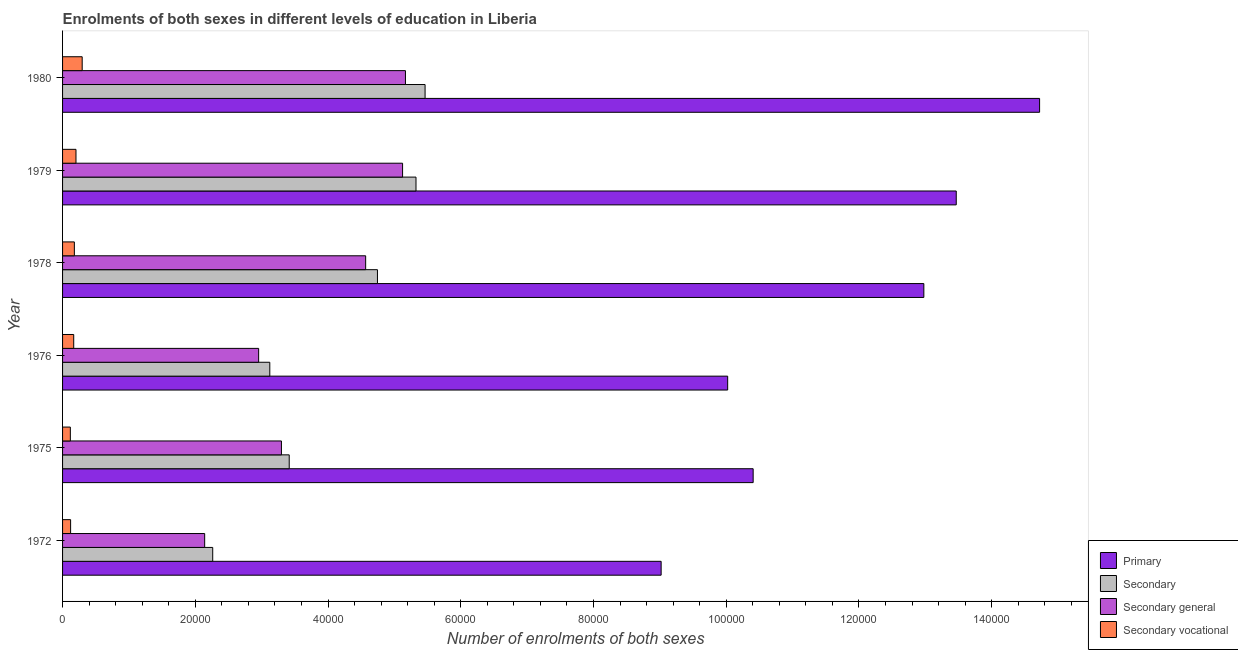How many different coloured bars are there?
Make the answer very short. 4. How many groups of bars are there?
Provide a short and direct response. 6. Are the number of bars on each tick of the Y-axis equal?
Your answer should be very brief. Yes. How many bars are there on the 5th tick from the top?
Provide a short and direct response. 4. How many bars are there on the 1st tick from the bottom?
Offer a very short reply. 4. What is the label of the 3rd group of bars from the top?
Provide a short and direct response. 1978. What is the number of enrolments in primary education in 1980?
Your response must be concise. 1.47e+05. Across all years, what is the maximum number of enrolments in secondary general education?
Make the answer very short. 5.17e+04. Across all years, what is the minimum number of enrolments in secondary general education?
Your answer should be very brief. 2.14e+04. In which year was the number of enrolments in secondary vocational education minimum?
Give a very brief answer. 1975. What is the total number of enrolments in primary education in the graph?
Your answer should be compact. 7.06e+05. What is the difference between the number of enrolments in secondary general education in 1979 and that in 1980?
Offer a very short reply. -435. What is the difference between the number of enrolments in secondary general education in 1978 and the number of enrolments in secondary vocational education in 1976?
Your response must be concise. 4.40e+04. What is the average number of enrolments in secondary vocational education per year?
Offer a very short reply. 1804. In the year 1978, what is the difference between the number of enrolments in secondary education and number of enrolments in secondary vocational education?
Offer a terse response. 4.57e+04. In how many years, is the number of enrolments in secondary general education greater than 60000 ?
Keep it short and to the point. 0. What is the ratio of the number of enrolments in secondary education in 1976 to that in 1978?
Keep it short and to the point. 0.66. What is the difference between the highest and the second highest number of enrolments in primary education?
Offer a terse response. 1.26e+04. What is the difference between the highest and the lowest number of enrolments in secondary general education?
Your answer should be very brief. 3.03e+04. Is the sum of the number of enrolments in primary education in 1979 and 1980 greater than the maximum number of enrolments in secondary education across all years?
Offer a very short reply. Yes. Is it the case that in every year, the sum of the number of enrolments in secondary vocational education and number of enrolments in secondary education is greater than the sum of number of enrolments in primary education and number of enrolments in secondary general education?
Your response must be concise. Yes. What does the 3rd bar from the top in 1980 represents?
Offer a very short reply. Secondary. What does the 4th bar from the bottom in 1976 represents?
Provide a succinct answer. Secondary vocational. How many years are there in the graph?
Make the answer very short. 6. What is the difference between two consecutive major ticks on the X-axis?
Keep it short and to the point. 2.00e+04. Are the values on the major ticks of X-axis written in scientific E-notation?
Keep it short and to the point. No. Does the graph contain any zero values?
Make the answer very short. No. How many legend labels are there?
Keep it short and to the point. 4. What is the title of the graph?
Ensure brevity in your answer.  Enrolments of both sexes in different levels of education in Liberia. What is the label or title of the X-axis?
Offer a terse response. Number of enrolments of both sexes. What is the label or title of the Y-axis?
Your response must be concise. Year. What is the Number of enrolments of both sexes of Primary in 1972?
Your answer should be very brief. 9.02e+04. What is the Number of enrolments of both sexes in Secondary in 1972?
Offer a very short reply. 2.26e+04. What is the Number of enrolments of both sexes in Secondary general in 1972?
Give a very brief answer. 2.14e+04. What is the Number of enrolments of both sexes in Secondary vocational in 1972?
Your response must be concise. 1213. What is the Number of enrolments of both sexes of Primary in 1975?
Offer a very short reply. 1.04e+05. What is the Number of enrolments of both sexes in Secondary in 1975?
Your answer should be very brief. 3.42e+04. What is the Number of enrolments of both sexes in Secondary general in 1975?
Ensure brevity in your answer.  3.30e+04. What is the Number of enrolments of both sexes of Secondary vocational in 1975?
Keep it short and to the point. 1173. What is the Number of enrolments of both sexes in Primary in 1976?
Provide a succinct answer. 1.00e+05. What is the Number of enrolments of both sexes of Secondary in 1976?
Offer a very short reply. 3.12e+04. What is the Number of enrolments of both sexes of Secondary general in 1976?
Your answer should be very brief. 2.95e+04. What is the Number of enrolments of both sexes of Secondary vocational in 1976?
Provide a succinct answer. 1680. What is the Number of enrolments of both sexes of Primary in 1978?
Your answer should be compact. 1.30e+05. What is the Number of enrolments of both sexes in Secondary in 1978?
Make the answer very short. 4.74e+04. What is the Number of enrolments of both sexes in Secondary general in 1978?
Keep it short and to the point. 4.57e+04. What is the Number of enrolments of both sexes in Secondary vocational in 1978?
Offer a terse response. 1778. What is the Number of enrolments of both sexes of Primary in 1979?
Offer a very short reply. 1.35e+05. What is the Number of enrolments of both sexes of Secondary in 1979?
Your answer should be very brief. 5.33e+04. What is the Number of enrolments of both sexes of Secondary general in 1979?
Keep it short and to the point. 5.12e+04. What is the Number of enrolments of both sexes of Secondary vocational in 1979?
Make the answer very short. 2023. What is the Number of enrolments of both sexes in Primary in 1980?
Give a very brief answer. 1.47e+05. What is the Number of enrolments of both sexes of Secondary in 1980?
Provide a short and direct response. 5.46e+04. What is the Number of enrolments of both sexes of Secondary general in 1980?
Your answer should be compact. 5.17e+04. What is the Number of enrolments of both sexes in Secondary vocational in 1980?
Your answer should be very brief. 2957. Across all years, what is the maximum Number of enrolments of both sexes of Primary?
Provide a succinct answer. 1.47e+05. Across all years, what is the maximum Number of enrolments of both sexes in Secondary?
Ensure brevity in your answer.  5.46e+04. Across all years, what is the maximum Number of enrolments of both sexes in Secondary general?
Offer a terse response. 5.17e+04. Across all years, what is the maximum Number of enrolments of both sexes in Secondary vocational?
Ensure brevity in your answer.  2957. Across all years, what is the minimum Number of enrolments of both sexes of Primary?
Your response must be concise. 9.02e+04. Across all years, what is the minimum Number of enrolments of both sexes of Secondary?
Ensure brevity in your answer.  2.26e+04. Across all years, what is the minimum Number of enrolments of both sexes of Secondary general?
Make the answer very short. 2.14e+04. Across all years, what is the minimum Number of enrolments of both sexes of Secondary vocational?
Your response must be concise. 1173. What is the total Number of enrolments of both sexes of Primary in the graph?
Make the answer very short. 7.06e+05. What is the total Number of enrolments of both sexes of Secondary in the graph?
Make the answer very short. 2.43e+05. What is the total Number of enrolments of both sexes in Secondary general in the graph?
Ensure brevity in your answer.  2.32e+05. What is the total Number of enrolments of both sexes of Secondary vocational in the graph?
Your answer should be very brief. 1.08e+04. What is the difference between the Number of enrolments of both sexes in Primary in 1972 and that in 1975?
Provide a succinct answer. -1.39e+04. What is the difference between the Number of enrolments of both sexes of Secondary in 1972 and that in 1975?
Offer a very short reply. -1.15e+04. What is the difference between the Number of enrolments of both sexes in Secondary general in 1972 and that in 1975?
Your answer should be compact. -1.16e+04. What is the difference between the Number of enrolments of both sexes of Primary in 1972 and that in 1976?
Provide a short and direct response. -1.00e+04. What is the difference between the Number of enrolments of both sexes in Secondary in 1972 and that in 1976?
Provide a succinct answer. -8600. What is the difference between the Number of enrolments of both sexes in Secondary general in 1972 and that in 1976?
Your response must be concise. -8133. What is the difference between the Number of enrolments of both sexes of Secondary vocational in 1972 and that in 1976?
Provide a succinct answer. -467. What is the difference between the Number of enrolments of both sexes of Primary in 1972 and that in 1978?
Keep it short and to the point. -3.96e+04. What is the difference between the Number of enrolments of both sexes in Secondary in 1972 and that in 1978?
Offer a terse response. -2.48e+04. What is the difference between the Number of enrolments of both sexes of Secondary general in 1972 and that in 1978?
Ensure brevity in your answer.  -2.43e+04. What is the difference between the Number of enrolments of both sexes of Secondary vocational in 1972 and that in 1978?
Your answer should be compact. -565. What is the difference between the Number of enrolments of both sexes of Primary in 1972 and that in 1979?
Keep it short and to the point. -4.45e+04. What is the difference between the Number of enrolments of both sexes in Secondary in 1972 and that in 1979?
Provide a succinct answer. -3.06e+04. What is the difference between the Number of enrolments of both sexes of Secondary general in 1972 and that in 1979?
Keep it short and to the point. -2.98e+04. What is the difference between the Number of enrolments of both sexes in Secondary vocational in 1972 and that in 1979?
Provide a succinct answer. -810. What is the difference between the Number of enrolments of both sexes of Primary in 1972 and that in 1980?
Offer a very short reply. -5.70e+04. What is the difference between the Number of enrolments of both sexes of Secondary in 1972 and that in 1980?
Offer a terse response. -3.20e+04. What is the difference between the Number of enrolments of both sexes in Secondary general in 1972 and that in 1980?
Your answer should be compact. -3.03e+04. What is the difference between the Number of enrolments of both sexes in Secondary vocational in 1972 and that in 1980?
Provide a short and direct response. -1744. What is the difference between the Number of enrolments of both sexes in Primary in 1975 and that in 1976?
Provide a short and direct response. 3839. What is the difference between the Number of enrolments of both sexes of Secondary in 1975 and that in 1976?
Provide a short and direct response. 2927. What is the difference between the Number of enrolments of both sexes of Secondary general in 1975 and that in 1976?
Offer a very short reply. 3434. What is the difference between the Number of enrolments of both sexes of Secondary vocational in 1975 and that in 1976?
Offer a terse response. -507. What is the difference between the Number of enrolments of both sexes in Primary in 1975 and that in 1978?
Provide a short and direct response. -2.57e+04. What is the difference between the Number of enrolments of both sexes of Secondary in 1975 and that in 1978?
Offer a terse response. -1.33e+04. What is the difference between the Number of enrolments of both sexes in Secondary general in 1975 and that in 1978?
Your answer should be very brief. -1.27e+04. What is the difference between the Number of enrolments of both sexes of Secondary vocational in 1975 and that in 1978?
Your answer should be compact. -605. What is the difference between the Number of enrolments of both sexes in Primary in 1975 and that in 1979?
Provide a succinct answer. -3.06e+04. What is the difference between the Number of enrolments of both sexes of Secondary in 1975 and that in 1979?
Your response must be concise. -1.91e+04. What is the difference between the Number of enrolments of both sexes of Secondary general in 1975 and that in 1979?
Keep it short and to the point. -1.83e+04. What is the difference between the Number of enrolments of both sexes in Secondary vocational in 1975 and that in 1979?
Your response must be concise. -850. What is the difference between the Number of enrolments of both sexes of Primary in 1975 and that in 1980?
Keep it short and to the point. -4.32e+04. What is the difference between the Number of enrolments of both sexes in Secondary in 1975 and that in 1980?
Offer a terse response. -2.05e+04. What is the difference between the Number of enrolments of both sexes in Secondary general in 1975 and that in 1980?
Ensure brevity in your answer.  -1.87e+04. What is the difference between the Number of enrolments of both sexes in Secondary vocational in 1975 and that in 1980?
Offer a terse response. -1784. What is the difference between the Number of enrolments of both sexes of Primary in 1976 and that in 1978?
Your answer should be compact. -2.96e+04. What is the difference between the Number of enrolments of both sexes in Secondary in 1976 and that in 1978?
Offer a very short reply. -1.62e+04. What is the difference between the Number of enrolments of both sexes in Secondary general in 1976 and that in 1978?
Your response must be concise. -1.61e+04. What is the difference between the Number of enrolments of both sexes of Secondary vocational in 1976 and that in 1978?
Offer a terse response. -98. What is the difference between the Number of enrolments of both sexes in Primary in 1976 and that in 1979?
Offer a terse response. -3.44e+04. What is the difference between the Number of enrolments of both sexes in Secondary in 1976 and that in 1979?
Your response must be concise. -2.20e+04. What is the difference between the Number of enrolments of both sexes in Secondary general in 1976 and that in 1979?
Make the answer very short. -2.17e+04. What is the difference between the Number of enrolments of both sexes of Secondary vocational in 1976 and that in 1979?
Make the answer very short. -343. What is the difference between the Number of enrolments of both sexes of Primary in 1976 and that in 1980?
Ensure brevity in your answer.  -4.70e+04. What is the difference between the Number of enrolments of both sexes of Secondary in 1976 and that in 1980?
Offer a terse response. -2.34e+04. What is the difference between the Number of enrolments of both sexes of Secondary general in 1976 and that in 1980?
Provide a succinct answer. -2.21e+04. What is the difference between the Number of enrolments of both sexes of Secondary vocational in 1976 and that in 1980?
Your response must be concise. -1277. What is the difference between the Number of enrolments of both sexes in Primary in 1978 and that in 1979?
Your answer should be compact. -4882. What is the difference between the Number of enrolments of both sexes of Secondary in 1978 and that in 1979?
Make the answer very short. -5808. What is the difference between the Number of enrolments of both sexes of Secondary general in 1978 and that in 1979?
Ensure brevity in your answer.  -5563. What is the difference between the Number of enrolments of both sexes in Secondary vocational in 1978 and that in 1979?
Provide a short and direct response. -245. What is the difference between the Number of enrolments of both sexes in Primary in 1978 and that in 1980?
Keep it short and to the point. -1.74e+04. What is the difference between the Number of enrolments of both sexes of Secondary in 1978 and that in 1980?
Make the answer very short. -7177. What is the difference between the Number of enrolments of both sexes in Secondary general in 1978 and that in 1980?
Offer a terse response. -5998. What is the difference between the Number of enrolments of both sexes in Secondary vocational in 1978 and that in 1980?
Your answer should be very brief. -1179. What is the difference between the Number of enrolments of both sexes in Primary in 1979 and that in 1980?
Make the answer very short. -1.26e+04. What is the difference between the Number of enrolments of both sexes of Secondary in 1979 and that in 1980?
Offer a terse response. -1369. What is the difference between the Number of enrolments of both sexes in Secondary general in 1979 and that in 1980?
Make the answer very short. -435. What is the difference between the Number of enrolments of both sexes of Secondary vocational in 1979 and that in 1980?
Provide a short and direct response. -934. What is the difference between the Number of enrolments of both sexes of Primary in 1972 and the Number of enrolments of both sexes of Secondary in 1975?
Give a very brief answer. 5.60e+04. What is the difference between the Number of enrolments of both sexes of Primary in 1972 and the Number of enrolments of both sexes of Secondary general in 1975?
Your answer should be compact. 5.72e+04. What is the difference between the Number of enrolments of both sexes in Primary in 1972 and the Number of enrolments of both sexes in Secondary vocational in 1975?
Ensure brevity in your answer.  8.90e+04. What is the difference between the Number of enrolments of both sexes in Secondary in 1972 and the Number of enrolments of both sexes in Secondary general in 1975?
Make the answer very short. -1.04e+04. What is the difference between the Number of enrolments of both sexes in Secondary in 1972 and the Number of enrolments of both sexes in Secondary vocational in 1975?
Make the answer very short. 2.15e+04. What is the difference between the Number of enrolments of both sexes of Secondary general in 1972 and the Number of enrolments of both sexes of Secondary vocational in 1975?
Keep it short and to the point. 2.02e+04. What is the difference between the Number of enrolments of both sexes in Primary in 1972 and the Number of enrolments of both sexes in Secondary in 1976?
Your answer should be very brief. 5.90e+04. What is the difference between the Number of enrolments of both sexes of Primary in 1972 and the Number of enrolments of both sexes of Secondary general in 1976?
Your answer should be compact. 6.06e+04. What is the difference between the Number of enrolments of both sexes in Primary in 1972 and the Number of enrolments of both sexes in Secondary vocational in 1976?
Offer a very short reply. 8.85e+04. What is the difference between the Number of enrolments of both sexes of Secondary in 1972 and the Number of enrolments of both sexes of Secondary general in 1976?
Give a very brief answer. -6920. What is the difference between the Number of enrolments of both sexes in Secondary in 1972 and the Number of enrolments of both sexes in Secondary vocational in 1976?
Make the answer very short. 2.09e+04. What is the difference between the Number of enrolments of both sexes of Secondary general in 1972 and the Number of enrolments of both sexes of Secondary vocational in 1976?
Give a very brief answer. 1.97e+04. What is the difference between the Number of enrolments of both sexes of Primary in 1972 and the Number of enrolments of both sexes of Secondary in 1978?
Give a very brief answer. 4.27e+04. What is the difference between the Number of enrolments of both sexes in Primary in 1972 and the Number of enrolments of both sexes in Secondary general in 1978?
Your answer should be compact. 4.45e+04. What is the difference between the Number of enrolments of both sexes in Primary in 1972 and the Number of enrolments of both sexes in Secondary vocational in 1978?
Your answer should be compact. 8.84e+04. What is the difference between the Number of enrolments of both sexes in Secondary in 1972 and the Number of enrolments of both sexes in Secondary general in 1978?
Your answer should be very brief. -2.30e+04. What is the difference between the Number of enrolments of both sexes of Secondary in 1972 and the Number of enrolments of both sexes of Secondary vocational in 1978?
Keep it short and to the point. 2.08e+04. What is the difference between the Number of enrolments of both sexes of Secondary general in 1972 and the Number of enrolments of both sexes of Secondary vocational in 1978?
Provide a short and direct response. 1.96e+04. What is the difference between the Number of enrolments of both sexes of Primary in 1972 and the Number of enrolments of both sexes of Secondary in 1979?
Make the answer very short. 3.69e+04. What is the difference between the Number of enrolments of both sexes of Primary in 1972 and the Number of enrolments of both sexes of Secondary general in 1979?
Keep it short and to the point. 3.90e+04. What is the difference between the Number of enrolments of both sexes in Primary in 1972 and the Number of enrolments of both sexes in Secondary vocational in 1979?
Your answer should be compact. 8.82e+04. What is the difference between the Number of enrolments of both sexes of Secondary in 1972 and the Number of enrolments of both sexes of Secondary general in 1979?
Make the answer very short. -2.86e+04. What is the difference between the Number of enrolments of both sexes of Secondary in 1972 and the Number of enrolments of both sexes of Secondary vocational in 1979?
Provide a short and direct response. 2.06e+04. What is the difference between the Number of enrolments of both sexes in Secondary general in 1972 and the Number of enrolments of both sexes in Secondary vocational in 1979?
Provide a succinct answer. 1.94e+04. What is the difference between the Number of enrolments of both sexes of Primary in 1972 and the Number of enrolments of both sexes of Secondary in 1980?
Offer a terse response. 3.56e+04. What is the difference between the Number of enrolments of both sexes of Primary in 1972 and the Number of enrolments of both sexes of Secondary general in 1980?
Provide a short and direct response. 3.85e+04. What is the difference between the Number of enrolments of both sexes in Primary in 1972 and the Number of enrolments of both sexes in Secondary vocational in 1980?
Your response must be concise. 8.72e+04. What is the difference between the Number of enrolments of both sexes in Secondary in 1972 and the Number of enrolments of both sexes in Secondary general in 1980?
Provide a short and direct response. -2.90e+04. What is the difference between the Number of enrolments of both sexes in Secondary in 1972 and the Number of enrolments of both sexes in Secondary vocational in 1980?
Offer a terse response. 1.97e+04. What is the difference between the Number of enrolments of both sexes in Secondary general in 1972 and the Number of enrolments of both sexes in Secondary vocational in 1980?
Your response must be concise. 1.85e+04. What is the difference between the Number of enrolments of both sexes of Primary in 1975 and the Number of enrolments of both sexes of Secondary in 1976?
Ensure brevity in your answer.  7.28e+04. What is the difference between the Number of enrolments of both sexes in Primary in 1975 and the Number of enrolments of both sexes in Secondary general in 1976?
Provide a succinct answer. 7.45e+04. What is the difference between the Number of enrolments of both sexes of Primary in 1975 and the Number of enrolments of both sexes of Secondary vocational in 1976?
Provide a succinct answer. 1.02e+05. What is the difference between the Number of enrolments of both sexes of Secondary in 1975 and the Number of enrolments of both sexes of Secondary general in 1976?
Ensure brevity in your answer.  4607. What is the difference between the Number of enrolments of both sexes in Secondary in 1975 and the Number of enrolments of both sexes in Secondary vocational in 1976?
Offer a terse response. 3.25e+04. What is the difference between the Number of enrolments of both sexes of Secondary general in 1975 and the Number of enrolments of both sexes of Secondary vocational in 1976?
Your answer should be compact. 3.13e+04. What is the difference between the Number of enrolments of both sexes of Primary in 1975 and the Number of enrolments of both sexes of Secondary in 1978?
Ensure brevity in your answer.  5.66e+04. What is the difference between the Number of enrolments of both sexes in Primary in 1975 and the Number of enrolments of both sexes in Secondary general in 1978?
Keep it short and to the point. 5.84e+04. What is the difference between the Number of enrolments of both sexes in Primary in 1975 and the Number of enrolments of both sexes in Secondary vocational in 1978?
Your response must be concise. 1.02e+05. What is the difference between the Number of enrolments of both sexes in Secondary in 1975 and the Number of enrolments of both sexes in Secondary general in 1978?
Offer a very short reply. -1.15e+04. What is the difference between the Number of enrolments of both sexes in Secondary in 1975 and the Number of enrolments of both sexes in Secondary vocational in 1978?
Your answer should be very brief. 3.24e+04. What is the difference between the Number of enrolments of both sexes in Secondary general in 1975 and the Number of enrolments of both sexes in Secondary vocational in 1978?
Make the answer very short. 3.12e+04. What is the difference between the Number of enrolments of both sexes in Primary in 1975 and the Number of enrolments of both sexes in Secondary in 1979?
Offer a terse response. 5.08e+04. What is the difference between the Number of enrolments of both sexes of Primary in 1975 and the Number of enrolments of both sexes of Secondary general in 1979?
Offer a very short reply. 5.28e+04. What is the difference between the Number of enrolments of both sexes in Primary in 1975 and the Number of enrolments of both sexes in Secondary vocational in 1979?
Your answer should be compact. 1.02e+05. What is the difference between the Number of enrolments of both sexes in Secondary in 1975 and the Number of enrolments of both sexes in Secondary general in 1979?
Give a very brief answer. -1.71e+04. What is the difference between the Number of enrolments of both sexes of Secondary in 1975 and the Number of enrolments of both sexes of Secondary vocational in 1979?
Your response must be concise. 3.21e+04. What is the difference between the Number of enrolments of both sexes in Secondary general in 1975 and the Number of enrolments of both sexes in Secondary vocational in 1979?
Make the answer very short. 3.10e+04. What is the difference between the Number of enrolments of both sexes of Primary in 1975 and the Number of enrolments of both sexes of Secondary in 1980?
Offer a terse response. 4.94e+04. What is the difference between the Number of enrolments of both sexes of Primary in 1975 and the Number of enrolments of both sexes of Secondary general in 1980?
Offer a terse response. 5.24e+04. What is the difference between the Number of enrolments of both sexes of Primary in 1975 and the Number of enrolments of both sexes of Secondary vocational in 1980?
Keep it short and to the point. 1.01e+05. What is the difference between the Number of enrolments of both sexes in Secondary in 1975 and the Number of enrolments of both sexes in Secondary general in 1980?
Make the answer very short. -1.75e+04. What is the difference between the Number of enrolments of both sexes of Secondary in 1975 and the Number of enrolments of both sexes of Secondary vocational in 1980?
Offer a terse response. 3.12e+04. What is the difference between the Number of enrolments of both sexes of Secondary general in 1975 and the Number of enrolments of both sexes of Secondary vocational in 1980?
Your response must be concise. 3.00e+04. What is the difference between the Number of enrolments of both sexes in Primary in 1976 and the Number of enrolments of both sexes in Secondary in 1978?
Keep it short and to the point. 5.28e+04. What is the difference between the Number of enrolments of both sexes of Primary in 1976 and the Number of enrolments of both sexes of Secondary general in 1978?
Keep it short and to the point. 5.45e+04. What is the difference between the Number of enrolments of both sexes in Primary in 1976 and the Number of enrolments of both sexes in Secondary vocational in 1978?
Keep it short and to the point. 9.84e+04. What is the difference between the Number of enrolments of both sexes of Secondary in 1976 and the Number of enrolments of both sexes of Secondary general in 1978?
Provide a short and direct response. -1.44e+04. What is the difference between the Number of enrolments of both sexes in Secondary in 1976 and the Number of enrolments of both sexes in Secondary vocational in 1978?
Make the answer very short. 2.94e+04. What is the difference between the Number of enrolments of both sexes of Secondary general in 1976 and the Number of enrolments of both sexes of Secondary vocational in 1978?
Offer a very short reply. 2.78e+04. What is the difference between the Number of enrolments of both sexes in Primary in 1976 and the Number of enrolments of both sexes in Secondary in 1979?
Ensure brevity in your answer.  4.70e+04. What is the difference between the Number of enrolments of both sexes of Primary in 1976 and the Number of enrolments of both sexes of Secondary general in 1979?
Provide a short and direct response. 4.90e+04. What is the difference between the Number of enrolments of both sexes of Primary in 1976 and the Number of enrolments of both sexes of Secondary vocational in 1979?
Ensure brevity in your answer.  9.82e+04. What is the difference between the Number of enrolments of both sexes of Secondary in 1976 and the Number of enrolments of both sexes of Secondary general in 1979?
Your answer should be compact. -2.00e+04. What is the difference between the Number of enrolments of both sexes in Secondary in 1976 and the Number of enrolments of both sexes in Secondary vocational in 1979?
Your answer should be compact. 2.92e+04. What is the difference between the Number of enrolments of both sexes of Secondary general in 1976 and the Number of enrolments of both sexes of Secondary vocational in 1979?
Your answer should be compact. 2.75e+04. What is the difference between the Number of enrolments of both sexes of Primary in 1976 and the Number of enrolments of both sexes of Secondary in 1980?
Your answer should be very brief. 4.56e+04. What is the difference between the Number of enrolments of both sexes in Primary in 1976 and the Number of enrolments of both sexes in Secondary general in 1980?
Provide a succinct answer. 4.86e+04. What is the difference between the Number of enrolments of both sexes of Primary in 1976 and the Number of enrolments of both sexes of Secondary vocational in 1980?
Your answer should be compact. 9.73e+04. What is the difference between the Number of enrolments of both sexes in Secondary in 1976 and the Number of enrolments of both sexes in Secondary general in 1980?
Provide a short and direct response. -2.04e+04. What is the difference between the Number of enrolments of both sexes in Secondary in 1976 and the Number of enrolments of both sexes in Secondary vocational in 1980?
Provide a succinct answer. 2.83e+04. What is the difference between the Number of enrolments of both sexes of Secondary general in 1976 and the Number of enrolments of both sexes of Secondary vocational in 1980?
Offer a very short reply. 2.66e+04. What is the difference between the Number of enrolments of both sexes of Primary in 1978 and the Number of enrolments of both sexes of Secondary in 1979?
Offer a very short reply. 7.65e+04. What is the difference between the Number of enrolments of both sexes in Primary in 1978 and the Number of enrolments of both sexes in Secondary general in 1979?
Offer a very short reply. 7.85e+04. What is the difference between the Number of enrolments of both sexes of Primary in 1978 and the Number of enrolments of both sexes of Secondary vocational in 1979?
Offer a very short reply. 1.28e+05. What is the difference between the Number of enrolments of both sexes in Secondary in 1978 and the Number of enrolments of both sexes in Secondary general in 1979?
Offer a terse response. -3785. What is the difference between the Number of enrolments of both sexes of Secondary in 1978 and the Number of enrolments of both sexes of Secondary vocational in 1979?
Make the answer very short. 4.54e+04. What is the difference between the Number of enrolments of both sexes of Secondary general in 1978 and the Number of enrolments of both sexes of Secondary vocational in 1979?
Keep it short and to the point. 4.36e+04. What is the difference between the Number of enrolments of both sexes in Primary in 1978 and the Number of enrolments of both sexes in Secondary in 1980?
Keep it short and to the point. 7.52e+04. What is the difference between the Number of enrolments of both sexes of Primary in 1978 and the Number of enrolments of both sexes of Secondary general in 1980?
Provide a short and direct response. 7.81e+04. What is the difference between the Number of enrolments of both sexes in Primary in 1978 and the Number of enrolments of both sexes in Secondary vocational in 1980?
Your response must be concise. 1.27e+05. What is the difference between the Number of enrolments of both sexes in Secondary in 1978 and the Number of enrolments of both sexes in Secondary general in 1980?
Your answer should be very brief. -4220. What is the difference between the Number of enrolments of both sexes in Secondary in 1978 and the Number of enrolments of both sexes in Secondary vocational in 1980?
Give a very brief answer. 4.45e+04. What is the difference between the Number of enrolments of both sexes in Secondary general in 1978 and the Number of enrolments of both sexes in Secondary vocational in 1980?
Your answer should be very brief. 4.27e+04. What is the difference between the Number of enrolments of both sexes of Primary in 1979 and the Number of enrolments of both sexes of Secondary in 1980?
Ensure brevity in your answer.  8.00e+04. What is the difference between the Number of enrolments of both sexes in Primary in 1979 and the Number of enrolments of both sexes in Secondary general in 1980?
Ensure brevity in your answer.  8.30e+04. What is the difference between the Number of enrolments of both sexes in Primary in 1979 and the Number of enrolments of both sexes in Secondary vocational in 1980?
Your answer should be very brief. 1.32e+05. What is the difference between the Number of enrolments of both sexes in Secondary in 1979 and the Number of enrolments of both sexes in Secondary general in 1980?
Provide a short and direct response. 1588. What is the difference between the Number of enrolments of both sexes of Secondary in 1979 and the Number of enrolments of both sexes of Secondary vocational in 1980?
Provide a succinct answer. 5.03e+04. What is the difference between the Number of enrolments of both sexes of Secondary general in 1979 and the Number of enrolments of both sexes of Secondary vocational in 1980?
Give a very brief answer. 4.83e+04. What is the average Number of enrolments of both sexes in Primary per year?
Provide a succinct answer. 1.18e+05. What is the average Number of enrolments of both sexes of Secondary per year?
Your answer should be compact. 4.06e+04. What is the average Number of enrolments of both sexes in Secondary general per year?
Provide a succinct answer. 3.87e+04. What is the average Number of enrolments of both sexes in Secondary vocational per year?
Give a very brief answer. 1804. In the year 1972, what is the difference between the Number of enrolments of both sexes of Primary and Number of enrolments of both sexes of Secondary?
Give a very brief answer. 6.76e+04. In the year 1972, what is the difference between the Number of enrolments of both sexes in Primary and Number of enrolments of both sexes in Secondary general?
Your response must be concise. 6.88e+04. In the year 1972, what is the difference between the Number of enrolments of both sexes of Primary and Number of enrolments of both sexes of Secondary vocational?
Make the answer very short. 8.90e+04. In the year 1972, what is the difference between the Number of enrolments of both sexes of Secondary and Number of enrolments of both sexes of Secondary general?
Your answer should be compact. 1213. In the year 1972, what is the difference between the Number of enrolments of both sexes in Secondary and Number of enrolments of both sexes in Secondary vocational?
Your response must be concise. 2.14e+04. In the year 1972, what is the difference between the Number of enrolments of both sexes in Secondary general and Number of enrolments of both sexes in Secondary vocational?
Make the answer very short. 2.02e+04. In the year 1975, what is the difference between the Number of enrolments of both sexes in Primary and Number of enrolments of both sexes in Secondary?
Keep it short and to the point. 6.99e+04. In the year 1975, what is the difference between the Number of enrolments of both sexes of Primary and Number of enrolments of both sexes of Secondary general?
Your answer should be very brief. 7.11e+04. In the year 1975, what is the difference between the Number of enrolments of both sexes of Primary and Number of enrolments of both sexes of Secondary vocational?
Your answer should be very brief. 1.03e+05. In the year 1975, what is the difference between the Number of enrolments of both sexes of Secondary and Number of enrolments of both sexes of Secondary general?
Offer a terse response. 1173. In the year 1975, what is the difference between the Number of enrolments of both sexes of Secondary and Number of enrolments of both sexes of Secondary vocational?
Your answer should be compact. 3.30e+04. In the year 1975, what is the difference between the Number of enrolments of both sexes in Secondary general and Number of enrolments of both sexes in Secondary vocational?
Your response must be concise. 3.18e+04. In the year 1976, what is the difference between the Number of enrolments of both sexes in Primary and Number of enrolments of both sexes in Secondary?
Provide a short and direct response. 6.90e+04. In the year 1976, what is the difference between the Number of enrolments of both sexes of Primary and Number of enrolments of both sexes of Secondary general?
Provide a short and direct response. 7.07e+04. In the year 1976, what is the difference between the Number of enrolments of both sexes in Primary and Number of enrolments of both sexes in Secondary vocational?
Your answer should be very brief. 9.85e+04. In the year 1976, what is the difference between the Number of enrolments of both sexes in Secondary and Number of enrolments of both sexes in Secondary general?
Make the answer very short. 1680. In the year 1976, what is the difference between the Number of enrolments of both sexes of Secondary and Number of enrolments of both sexes of Secondary vocational?
Ensure brevity in your answer.  2.95e+04. In the year 1976, what is the difference between the Number of enrolments of both sexes in Secondary general and Number of enrolments of both sexes in Secondary vocational?
Your answer should be compact. 2.79e+04. In the year 1978, what is the difference between the Number of enrolments of both sexes of Primary and Number of enrolments of both sexes of Secondary?
Your answer should be very brief. 8.23e+04. In the year 1978, what is the difference between the Number of enrolments of both sexes of Primary and Number of enrolments of both sexes of Secondary general?
Your answer should be very brief. 8.41e+04. In the year 1978, what is the difference between the Number of enrolments of both sexes of Primary and Number of enrolments of both sexes of Secondary vocational?
Offer a terse response. 1.28e+05. In the year 1978, what is the difference between the Number of enrolments of both sexes of Secondary and Number of enrolments of both sexes of Secondary general?
Make the answer very short. 1778. In the year 1978, what is the difference between the Number of enrolments of both sexes of Secondary and Number of enrolments of both sexes of Secondary vocational?
Your answer should be compact. 4.57e+04. In the year 1978, what is the difference between the Number of enrolments of both sexes of Secondary general and Number of enrolments of both sexes of Secondary vocational?
Keep it short and to the point. 4.39e+04. In the year 1979, what is the difference between the Number of enrolments of both sexes in Primary and Number of enrolments of both sexes in Secondary?
Offer a terse response. 8.14e+04. In the year 1979, what is the difference between the Number of enrolments of both sexes in Primary and Number of enrolments of both sexes in Secondary general?
Offer a terse response. 8.34e+04. In the year 1979, what is the difference between the Number of enrolments of both sexes of Primary and Number of enrolments of both sexes of Secondary vocational?
Provide a succinct answer. 1.33e+05. In the year 1979, what is the difference between the Number of enrolments of both sexes in Secondary and Number of enrolments of both sexes in Secondary general?
Your answer should be very brief. 2023. In the year 1979, what is the difference between the Number of enrolments of both sexes in Secondary and Number of enrolments of both sexes in Secondary vocational?
Your answer should be very brief. 5.12e+04. In the year 1979, what is the difference between the Number of enrolments of both sexes of Secondary general and Number of enrolments of both sexes of Secondary vocational?
Provide a succinct answer. 4.92e+04. In the year 1980, what is the difference between the Number of enrolments of both sexes in Primary and Number of enrolments of both sexes in Secondary?
Offer a very short reply. 9.26e+04. In the year 1980, what is the difference between the Number of enrolments of both sexes in Primary and Number of enrolments of both sexes in Secondary general?
Your answer should be very brief. 9.56e+04. In the year 1980, what is the difference between the Number of enrolments of both sexes of Primary and Number of enrolments of both sexes of Secondary vocational?
Ensure brevity in your answer.  1.44e+05. In the year 1980, what is the difference between the Number of enrolments of both sexes in Secondary and Number of enrolments of both sexes in Secondary general?
Your answer should be very brief. 2957. In the year 1980, what is the difference between the Number of enrolments of both sexes in Secondary and Number of enrolments of both sexes in Secondary vocational?
Your answer should be very brief. 5.17e+04. In the year 1980, what is the difference between the Number of enrolments of both sexes of Secondary general and Number of enrolments of both sexes of Secondary vocational?
Offer a very short reply. 4.87e+04. What is the ratio of the Number of enrolments of both sexes in Primary in 1972 to that in 1975?
Give a very brief answer. 0.87. What is the ratio of the Number of enrolments of both sexes in Secondary in 1972 to that in 1975?
Your answer should be compact. 0.66. What is the ratio of the Number of enrolments of both sexes of Secondary general in 1972 to that in 1975?
Offer a very short reply. 0.65. What is the ratio of the Number of enrolments of both sexes in Secondary vocational in 1972 to that in 1975?
Provide a short and direct response. 1.03. What is the ratio of the Number of enrolments of both sexes in Secondary in 1972 to that in 1976?
Give a very brief answer. 0.72. What is the ratio of the Number of enrolments of both sexes of Secondary general in 1972 to that in 1976?
Your answer should be compact. 0.72. What is the ratio of the Number of enrolments of both sexes in Secondary vocational in 1972 to that in 1976?
Ensure brevity in your answer.  0.72. What is the ratio of the Number of enrolments of both sexes of Primary in 1972 to that in 1978?
Provide a short and direct response. 0.69. What is the ratio of the Number of enrolments of both sexes of Secondary in 1972 to that in 1978?
Keep it short and to the point. 0.48. What is the ratio of the Number of enrolments of both sexes of Secondary general in 1972 to that in 1978?
Provide a succinct answer. 0.47. What is the ratio of the Number of enrolments of both sexes of Secondary vocational in 1972 to that in 1978?
Keep it short and to the point. 0.68. What is the ratio of the Number of enrolments of both sexes in Primary in 1972 to that in 1979?
Your response must be concise. 0.67. What is the ratio of the Number of enrolments of both sexes of Secondary in 1972 to that in 1979?
Make the answer very short. 0.42. What is the ratio of the Number of enrolments of both sexes of Secondary general in 1972 to that in 1979?
Ensure brevity in your answer.  0.42. What is the ratio of the Number of enrolments of both sexes of Secondary vocational in 1972 to that in 1979?
Make the answer very short. 0.6. What is the ratio of the Number of enrolments of both sexes in Primary in 1972 to that in 1980?
Make the answer very short. 0.61. What is the ratio of the Number of enrolments of both sexes in Secondary in 1972 to that in 1980?
Keep it short and to the point. 0.41. What is the ratio of the Number of enrolments of both sexes of Secondary general in 1972 to that in 1980?
Ensure brevity in your answer.  0.41. What is the ratio of the Number of enrolments of both sexes in Secondary vocational in 1972 to that in 1980?
Make the answer very short. 0.41. What is the ratio of the Number of enrolments of both sexes of Primary in 1975 to that in 1976?
Provide a short and direct response. 1.04. What is the ratio of the Number of enrolments of both sexes of Secondary in 1975 to that in 1976?
Keep it short and to the point. 1.09. What is the ratio of the Number of enrolments of both sexes of Secondary general in 1975 to that in 1976?
Your answer should be compact. 1.12. What is the ratio of the Number of enrolments of both sexes in Secondary vocational in 1975 to that in 1976?
Offer a terse response. 0.7. What is the ratio of the Number of enrolments of both sexes in Primary in 1975 to that in 1978?
Ensure brevity in your answer.  0.8. What is the ratio of the Number of enrolments of both sexes of Secondary in 1975 to that in 1978?
Keep it short and to the point. 0.72. What is the ratio of the Number of enrolments of both sexes of Secondary general in 1975 to that in 1978?
Make the answer very short. 0.72. What is the ratio of the Number of enrolments of both sexes in Secondary vocational in 1975 to that in 1978?
Your answer should be compact. 0.66. What is the ratio of the Number of enrolments of both sexes in Primary in 1975 to that in 1979?
Offer a very short reply. 0.77. What is the ratio of the Number of enrolments of both sexes in Secondary in 1975 to that in 1979?
Your answer should be compact. 0.64. What is the ratio of the Number of enrolments of both sexes in Secondary general in 1975 to that in 1979?
Offer a very short reply. 0.64. What is the ratio of the Number of enrolments of both sexes of Secondary vocational in 1975 to that in 1979?
Your response must be concise. 0.58. What is the ratio of the Number of enrolments of both sexes in Primary in 1975 to that in 1980?
Keep it short and to the point. 0.71. What is the ratio of the Number of enrolments of both sexes of Secondary in 1975 to that in 1980?
Offer a very short reply. 0.63. What is the ratio of the Number of enrolments of both sexes in Secondary general in 1975 to that in 1980?
Provide a succinct answer. 0.64. What is the ratio of the Number of enrolments of both sexes in Secondary vocational in 1975 to that in 1980?
Your answer should be very brief. 0.4. What is the ratio of the Number of enrolments of both sexes of Primary in 1976 to that in 1978?
Provide a succinct answer. 0.77. What is the ratio of the Number of enrolments of both sexes in Secondary in 1976 to that in 1978?
Offer a terse response. 0.66. What is the ratio of the Number of enrolments of both sexes in Secondary general in 1976 to that in 1978?
Give a very brief answer. 0.65. What is the ratio of the Number of enrolments of both sexes in Secondary vocational in 1976 to that in 1978?
Your answer should be compact. 0.94. What is the ratio of the Number of enrolments of both sexes in Primary in 1976 to that in 1979?
Provide a succinct answer. 0.74. What is the ratio of the Number of enrolments of both sexes in Secondary in 1976 to that in 1979?
Keep it short and to the point. 0.59. What is the ratio of the Number of enrolments of both sexes in Secondary general in 1976 to that in 1979?
Your answer should be very brief. 0.58. What is the ratio of the Number of enrolments of both sexes of Secondary vocational in 1976 to that in 1979?
Provide a short and direct response. 0.83. What is the ratio of the Number of enrolments of both sexes in Primary in 1976 to that in 1980?
Provide a succinct answer. 0.68. What is the ratio of the Number of enrolments of both sexes in Secondary in 1976 to that in 1980?
Provide a succinct answer. 0.57. What is the ratio of the Number of enrolments of both sexes in Secondary general in 1976 to that in 1980?
Offer a very short reply. 0.57. What is the ratio of the Number of enrolments of both sexes of Secondary vocational in 1976 to that in 1980?
Make the answer very short. 0.57. What is the ratio of the Number of enrolments of both sexes of Primary in 1978 to that in 1979?
Offer a very short reply. 0.96. What is the ratio of the Number of enrolments of both sexes in Secondary in 1978 to that in 1979?
Your answer should be very brief. 0.89. What is the ratio of the Number of enrolments of both sexes of Secondary general in 1978 to that in 1979?
Provide a short and direct response. 0.89. What is the ratio of the Number of enrolments of both sexes in Secondary vocational in 1978 to that in 1979?
Provide a short and direct response. 0.88. What is the ratio of the Number of enrolments of both sexes of Primary in 1978 to that in 1980?
Keep it short and to the point. 0.88. What is the ratio of the Number of enrolments of both sexes of Secondary in 1978 to that in 1980?
Your answer should be very brief. 0.87. What is the ratio of the Number of enrolments of both sexes of Secondary general in 1978 to that in 1980?
Your response must be concise. 0.88. What is the ratio of the Number of enrolments of both sexes in Secondary vocational in 1978 to that in 1980?
Give a very brief answer. 0.6. What is the ratio of the Number of enrolments of both sexes in Primary in 1979 to that in 1980?
Your answer should be compact. 0.91. What is the ratio of the Number of enrolments of both sexes in Secondary in 1979 to that in 1980?
Your answer should be compact. 0.97. What is the ratio of the Number of enrolments of both sexes of Secondary general in 1979 to that in 1980?
Provide a short and direct response. 0.99. What is the ratio of the Number of enrolments of both sexes in Secondary vocational in 1979 to that in 1980?
Offer a terse response. 0.68. What is the difference between the highest and the second highest Number of enrolments of both sexes in Primary?
Offer a terse response. 1.26e+04. What is the difference between the highest and the second highest Number of enrolments of both sexes of Secondary?
Give a very brief answer. 1369. What is the difference between the highest and the second highest Number of enrolments of both sexes of Secondary general?
Give a very brief answer. 435. What is the difference between the highest and the second highest Number of enrolments of both sexes in Secondary vocational?
Your answer should be compact. 934. What is the difference between the highest and the lowest Number of enrolments of both sexes of Primary?
Provide a succinct answer. 5.70e+04. What is the difference between the highest and the lowest Number of enrolments of both sexes in Secondary?
Your response must be concise. 3.20e+04. What is the difference between the highest and the lowest Number of enrolments of both sexes in Secondary general?
Give a very brief answer. 3.03e+04. What is the difference between the highest and the lowest Number of enrolments of both sexes of Secondary vocational?
Provide a short and direct response. 1784. 